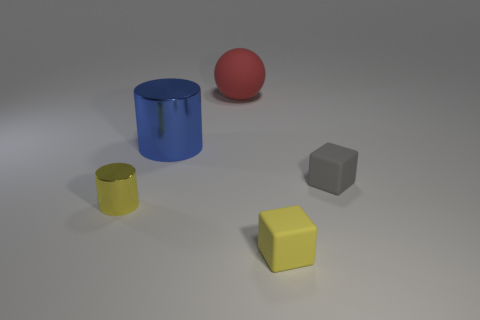Are there any other things that are the same shape as the big rubber object?
Provide a short and direct response. No. There is a tiny block behind the thing left of the big blue metallic thing; what number of tiny objects are in front of it?
Your answer should be compact. 2. What number of tiny cylinders are left of the large shiny thing?
Keep it short and to the point. 1. How many tiny blocks have the same material as the large cylinder?
Make the answer very short. 0. What is the color of the tiny object that is made of the same material as the blue cylinder?
Provide a succinct answer. Yellow. What is the cylinder in front of the tiny block that is on the right side of the small yellow thing that is in front of the yellow metal cylinder made of?
Give a very brief answer. Metal. There is a metal cylinder that is right of the yellow shiny thing; is it the same size as the tiny gray matte thing?
Offer a very short reply. No. How many small things are either brown spheres or yellow cubes?
Give a very brief answer. 1. Are there any matte cubes of the same color as the tiny cylinder?
Your response must be concise. Yes. What is the shape of the blue metallic thing that is the same size as the red rubber thing?
Your response must be concise. Cylinder. 